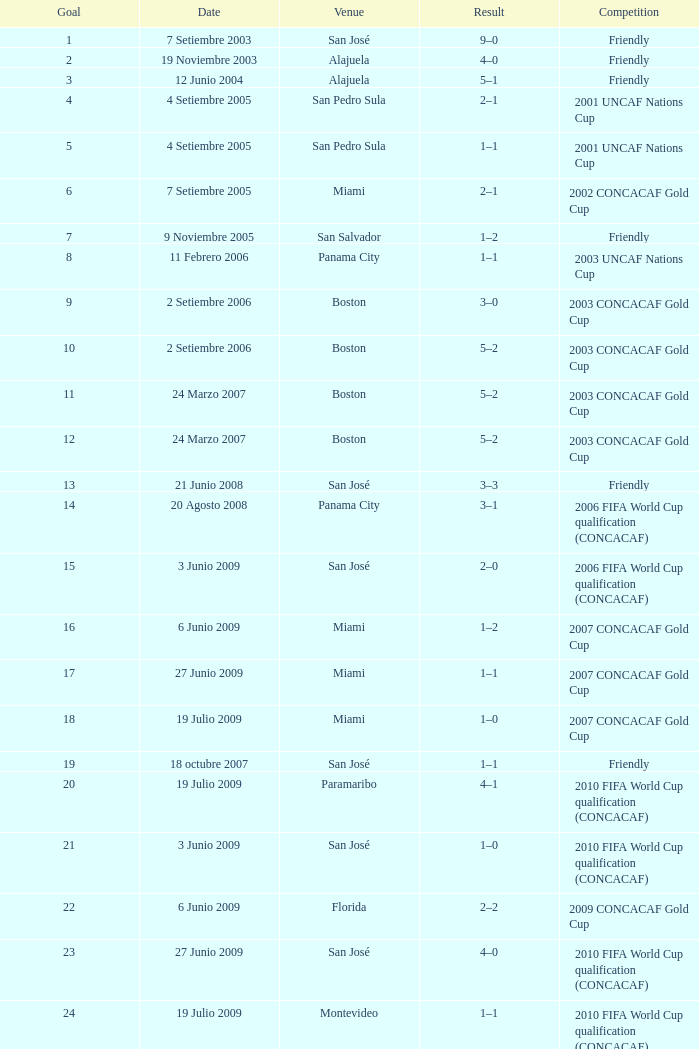What was the total number of goals scored on june 21, 2008? 1.0. 